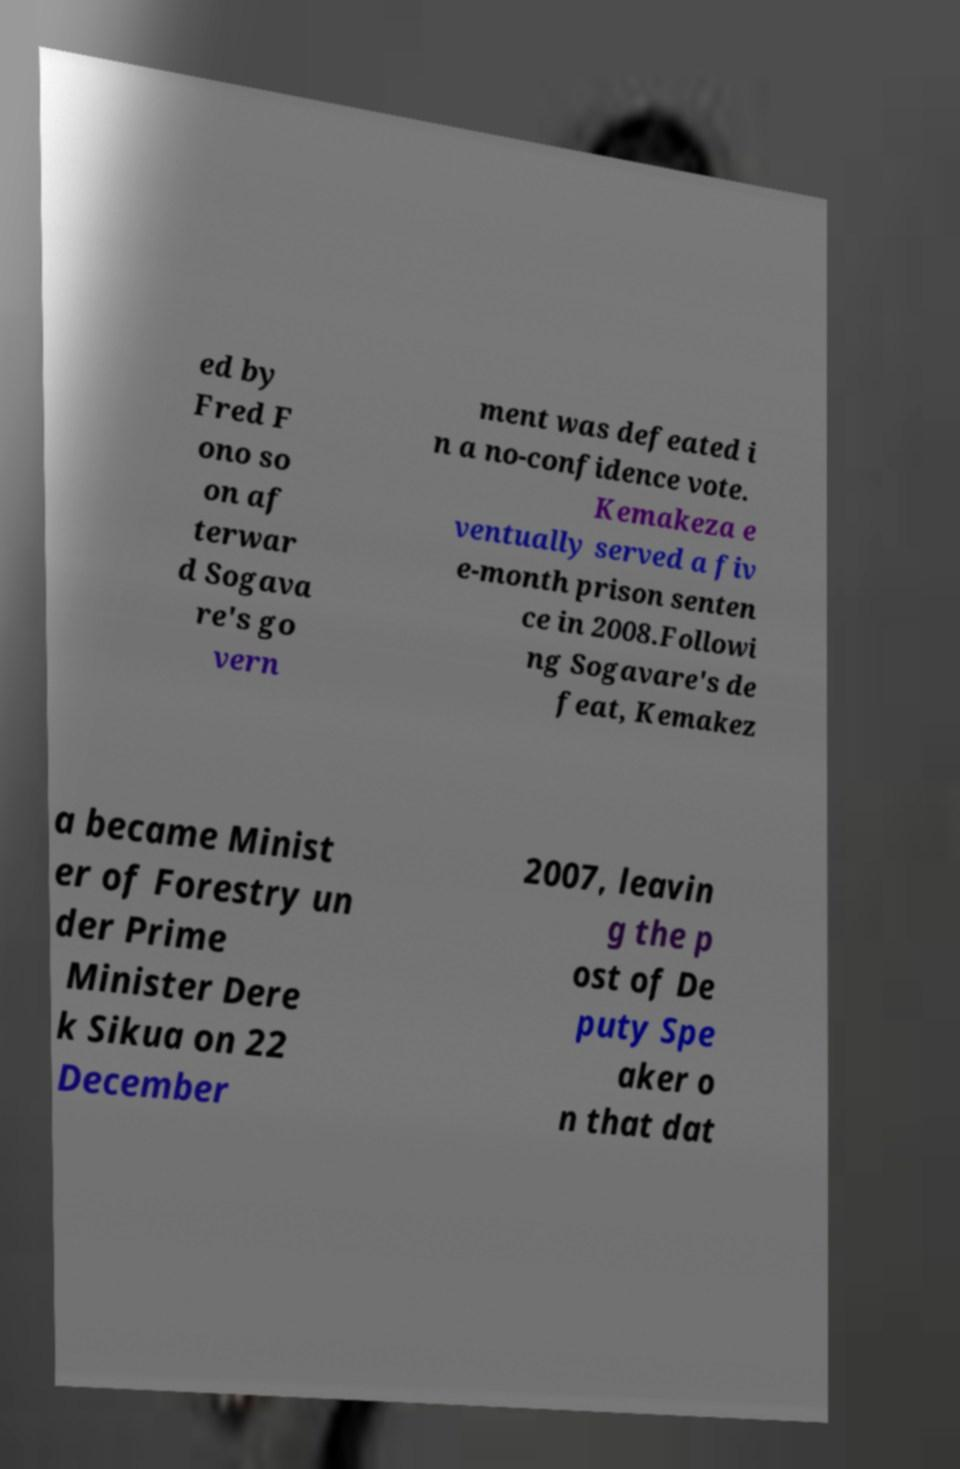Can you accurately transcribe the text from the provided image for me? ed by Fred F ono so on af terwar d Sogava re's go vern ment was defeated i n a no-confidence vote. Kemakeza e ventually served a fiv e-month prison senten ce in 2008.Followi ng Sogavare's de feat, Kemakez a became Minist er of Forestry un der Prime Minister Dere k Sikua on 22 December 2007, leavin g the p ost of De puty Spe aker o n that dat 